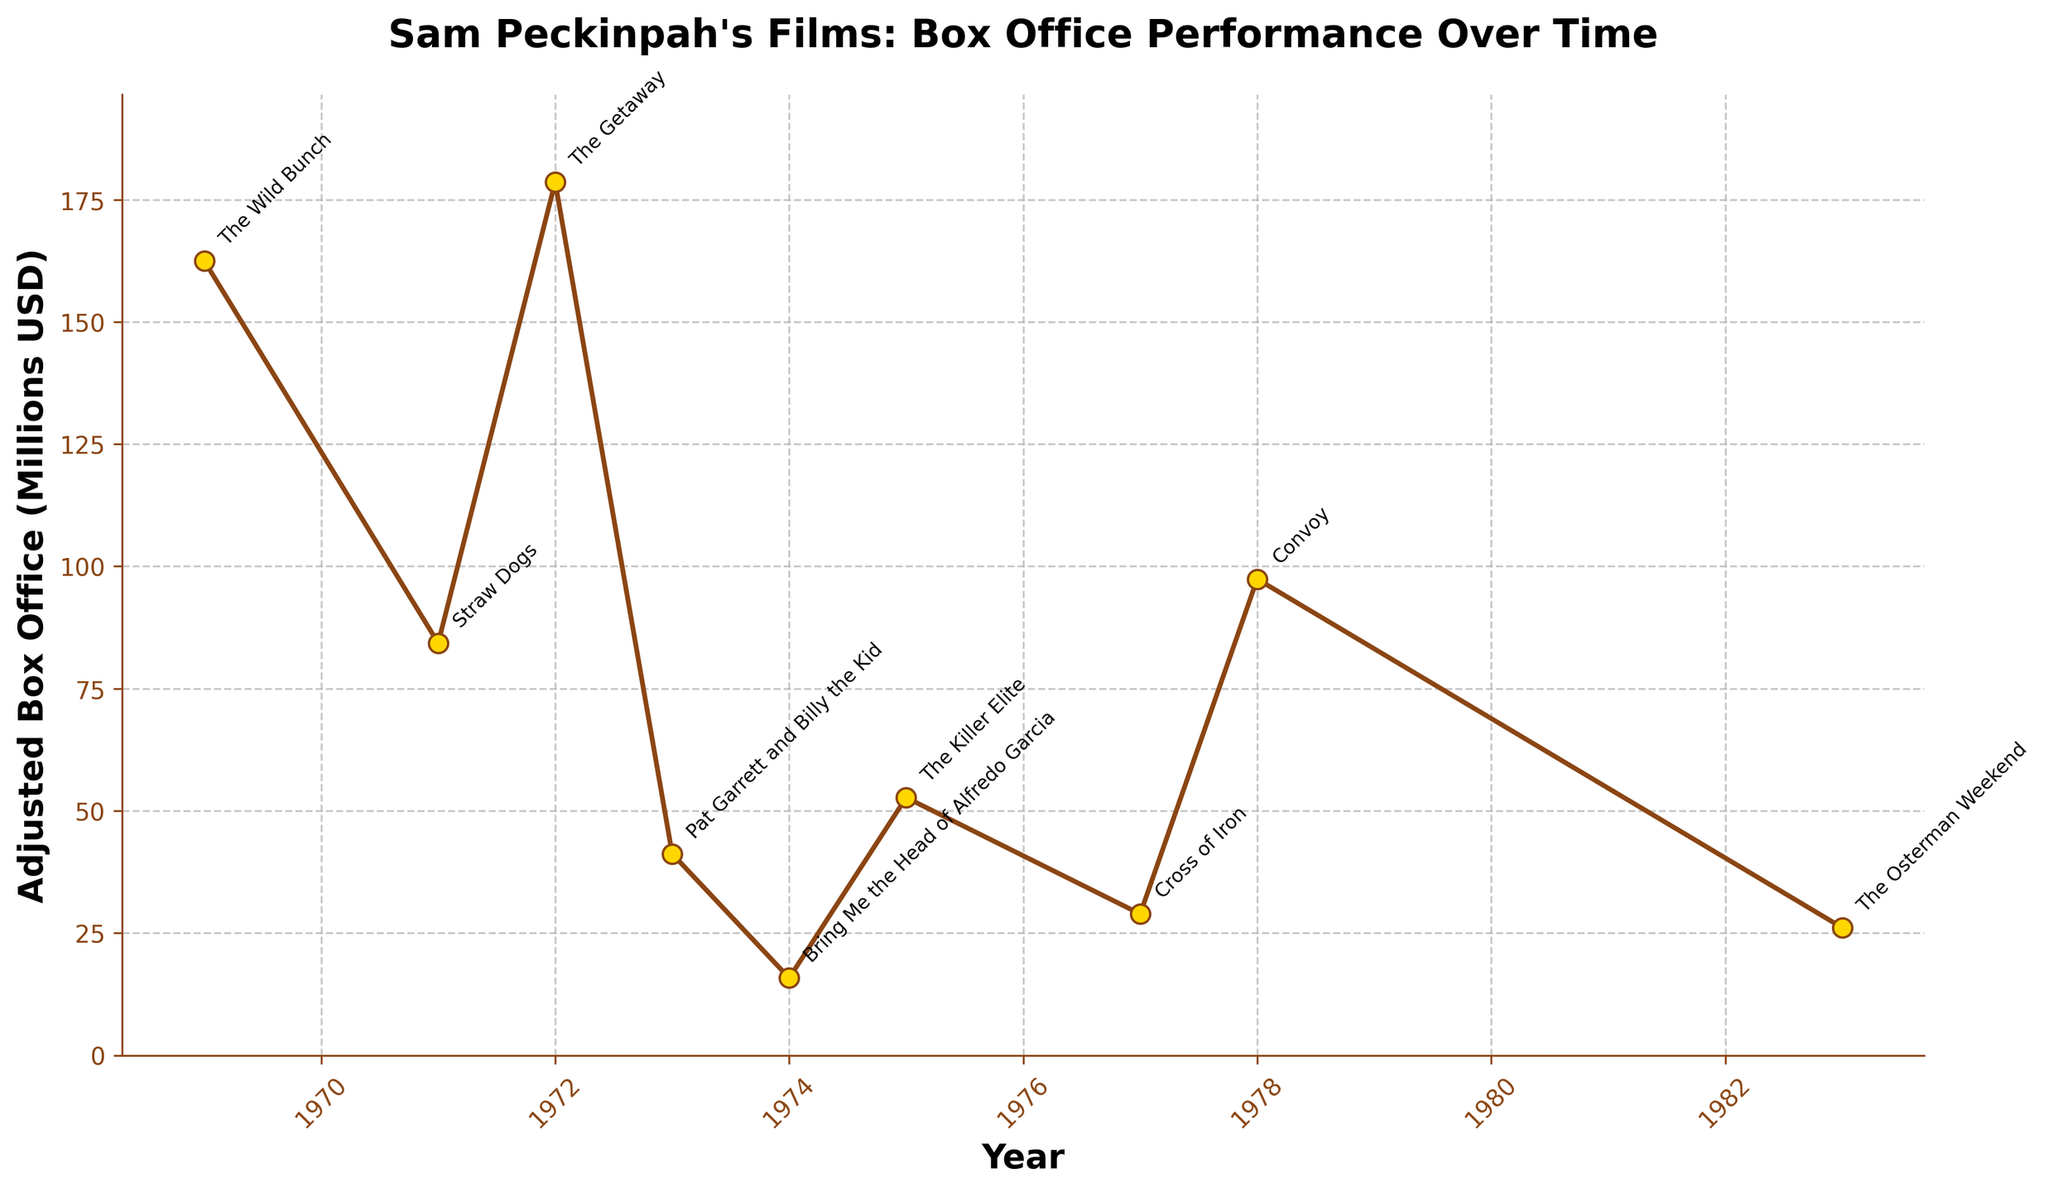What's the trend of box office performance over time for Sam Peckinpah's films? The trend shows peaks and troughs. The box office performance initially peaks in 1969 with "The Wild Bunch," then fluctuates, with another peak in 1972 with "The Getaway," before generally declining after 1978's "Convoy."
Answer: Peaks in 1969 and 1972, declines after 1978 Which film had the highest box office performance, and in which year was it released? "The Getaway" had the highest box office performance, released in 1972. This is seen as it has the highest point on the line chart.
Answer: "The Getaway" in 1972 How did "Bring Me the Head of Alfredo Garcia" perform compared to "Cross of Iron"? "Bring Me the Head of Alfredo Garcia" had significantly lower box office performance compared to "Cross of Iron." The respective values are around 15.8 million and 28.9 million USD.
Answer: Worse Which film had the lowest box office performance, and what was the figure? "Bring Me the Head of Alfredo Garcia" had the lowest box office performance with 15.8 million USD, the lowest point on the chart.
Answer: "Bring Me the Head of Alfredo Garcia" with 15.8 million USD What is the average box office performance of the films released between 1969 and 1974? The films from 1969 to 1974 are "The Wild Bunch," "Straw Dogs," "The Getaway," "Pat Garrett and Billy the Kid," and "Bring Me the Head of Alfredo Garcia." Their box office values are 162.5, 84.3, 178.6, 41.2, and 15.8 million respectively. The average is (162.5 + 84.3 + 178.6 + 41.2 + 15.8) / 5 = 482.4 / 5 = 96.48 million USD.
Answer: 96.48 million USD What was the difference in box office performance between "Convoy" and "The Osterman Weekend"? "Convoy" had a box office of 97.4 million USD, and "The Osterman Weekend" had 26.1 million USD. The difference is 97.4 - 26.1 = 71.3 million USD.
Answer: 71.3 million USD How did the box office of "The Wild Bunch" and "The Getaway" compare? "The Getaway" outperformed "The Wild Bunch" with box office figures of 178.6 million USD compared to 162.5 million USD.
Answer: "The Getaway" was higher What was the box office performance of Peckinpah's films in 1975 and how did it compare to 1977? In 1975, "The Killer Elite" had a box office performance of 52.7 million USD. In 1977, "Cross of Iron" had a performance of 28.9 million USD. The 1975 performance was higher.
Answer: 1975 was higher Which year saw the lowest box office performance and which film corresponds to it? 1974 saw the lowest box office performance with the film "Bring Me the Head of Alfredo Garcia" earning 15.8 million USD.
Answer: 1974 with "Bring Me the Head of Alfredo Garcia" 